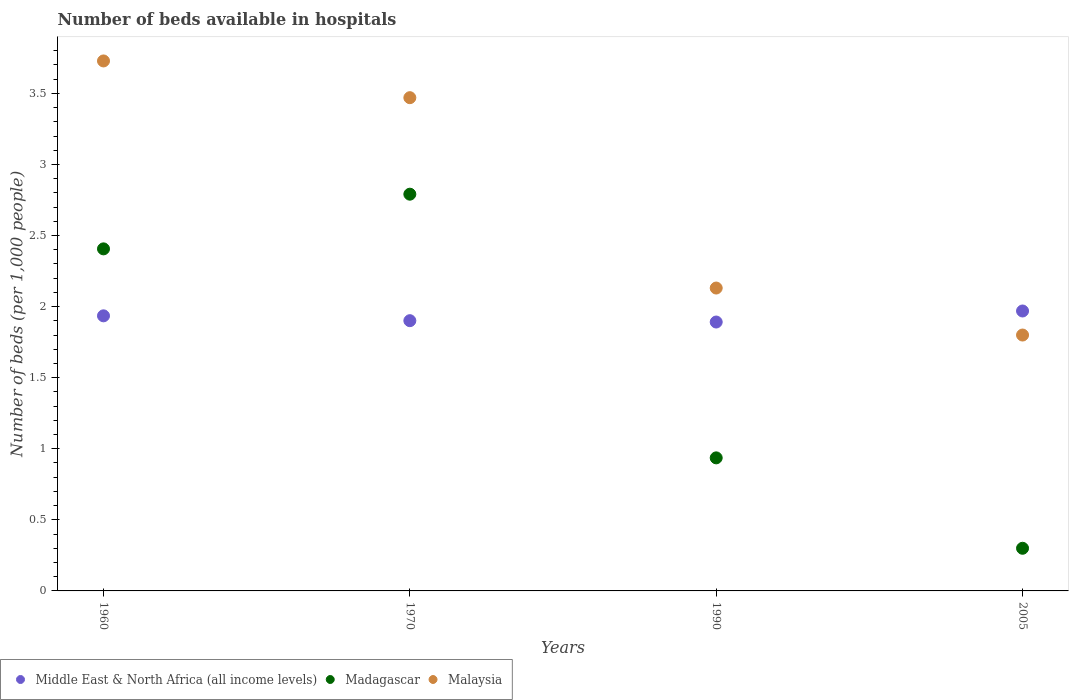How many different coloured dotlines are there?
Provide a short and direct response. 3. Is the number of dotlines equal to the number of legend labels?
Offer a terse response. Yes. What is the number of beds in the hospiatls of in Madagascar in 1990?
Your answer should be very brief. 0.94. Across all years, what is the maximum number of beds in the hospiatls of in Malaysia?
Make the answer very short. 3.73. Across all years, what is the minimum number of beds in the hospiatls of in Middle East & North Africa (all income levels)?
Offer a very short reply. 1.89. What is the total number of beds in the hospiatls of in Madagascar in the graph?
Your answer should be very brief. 6.43. What is the difference between the number of beds in the hospiatls of in Middle East & North Africa (all income levels) in 1960 and that in 1990?
Your response must be concise. 0.04. What is the difference between the number of beds in the hospiatls of in Middle East & North Africa (all income levels) in 1960 and the number of beds in the hospiatls of in Madagascar in 2005?
Keep it short and to the point. 1.64. What is the average number of beds in the hospiatls of in Middle East & North Africa (all income levels) per year?
Offer a very short reply. 1.92. In the year 2005, what is the difference between the number of beds in the hospiatls of in Madagascar and number of beds in the hospiatls of in Middle East & North Africa (all income levels)?
Give a very brief answer. -1.67. What is the ratio of the number of beds in the hospiatls of in Madagascar in 1960 to that in 2005?
Your response must be concise. 8.02. What is the difference between the highest and the second highest number of beds in the hospiatls of in Madagascar?
Provide a succinct answer. 0.38. What is the difference between the highest and the lowest number of beds in the hospiatls of in Malaysia?
Your response must be concise. 1.93. In how many years, is the number of beds in the hospiatls of in Middle East & North Africa (all income levels) greater than the average number of beds in the hospiatls of in Middle East & North Africa (all income levels) taken over all years?
Give a very brief answer. 2. Is the sum of the number of beds in the hospiatls of in Malaysia in 1970 and 2005 greater than the maximum number of beds in the hospiatls of in Middle East & North Africa (all income levels) across all years?
Offer a terse response. Yes. Is it the case that in every year, the sum of the number of beds in the hospiatls of in Middle East & North Africa (all income levels) and number of beds in the hospiatls of in Madagascar  is greater than the number of beds in the hospiatls of in Malaysia?
Provide a short and direct response. Yes. Is the number of beds in the hospiatls of in Middle East & North Africa (all income levels) strictly greater than the number of beds in the hospiatls of in Malaysia over the years?
Offer a very short reply. No. Is the number of beds in the hospiatls of in Middle East & North Africa (all income levels) strictly less than the number of beds in the hospiatls of in Madagascar over the years?
Your answer should be compact. No. Are the values on the major ticks of Y-axis written in scientific E-notation?
Your answer should be compact. No. Does the graph contain any zero values?
Your response must be concise. No. How many legend labels are there?
Offer a very short reply. 3. What is the title of the graph?
Your answer should be compact. Number of beds available in hospitals. What is the label or title of the X-axis?
Ensure brevity in your answer.  Years. What is the label or title of the Y-axis?
Provide a succinct answer. Number of beds (per 1,0 people). What is the Number of beds (per 1,000 people) of Middle East & North Africa (all income levels) in 1960?
Your response must be concise. 1.94. What is the Number of beds (per 1,000 people) of Madagascar in 1960?
Your answer should be very brief. 2.41. What is the Number of beds (per 1,000 people) in Malaysia in 1960?
Give a very brief answer. 3.73. What is the Number of beds (per 1,000 people) of Middle East & North Africa (all income levels) in 1970?
Provide a succinct answer. 1.9. What is the Number of beds (per 1,000 people) in Madagascar in 1970?
Keep it short and to the point. 2.79. What is the Number of beds (per 1,000 people) in Malaysia in 1970?
Your answer should be compact. 3.47. What is the Number of beds (per 1,000 people) of Middle East & North Africa (all income levels) in 1990?
Give a very brief answer. 1.89. What is the Number of beds (per 1,000 people) in Madagascar in 1990?
Your answer should be compact. 0.94. What is the Number of beds (per 1,000 people) in Malaysia in 1990?
Provide a short and direct response. 2.13. What is the Number of beds (per 1,000 people) of Middle East & North Africa (all income levels) in 2005?
Ensure brevity in your answer.  1.97. What is the Number of beds (per 1,000 people) in Madagascar in 2005?
Ensure brevity in your answer.  0.3. What is the Number of beds (per 1,000 people) of Malaysia in 2005?
Provide a succinct answer. 1.8. Across all years, what is the maximum Number of beds (per 1,000 people) of Middle East & North Africa (all income levels)?
Provide a succinct answer. 1.97. Across all years, what is the maximum Number of beds (per 1,000 people) of Madagascar?
Provide a succinct answer. 2.79. Across all years, what is the maximum Number of beds (per 1,000 people) of Malaysia?
Provide a short and direct response. 3.73. Across all years, what is the minimum Number of beds (per 1,000 people) in Middle East & North Africa (all income levels)?
Make the answer very short. 1.89. Across all years, what is the minimum Number of beds (per 1,000 people) in Madagascar?
Your response must be concise. 0.3. What is the total Number of beds (per 1,000 people) of Middle East & North Africa (all income levels) in the graph?
Offer a very short reply. 7.7. What is the total Number of beds (per 1,000 people) in Madagascar in the graph?
Provide a short and direct response. 6.43. What is the total Number of beds (per 1,000 people) of Malaysia in the graph?
Offer a terse response. 11.13. What is the difference between the Number of beds (per 1,000 people) in Middle East & North Africa (all income levels) in 1960 and that in 1970?
Ensure brevity in your answer.  0.03. What is the difference between the Number of beds (per 1,000 people) of Madagascar in 1960 and that in 1970?
Make the answer very short. -0.38. What is the difference between the Number of beds (per 1,000 people) of Malaysia in 1960 and that in 1970?
Keep it short and to the point. 0.26. What is the difference between the Number of beds (per 1,000 people) in Middle East & North Africa (all income levels) in 1960 and that in 1990?
Provide a short and direct response. 0.04. What is the difference between the Number of beds (per 1,000 people) in Madagascar in 1960 and that in 1990?
Offer a terse response. 1.47. What is the difference between the Number of beds (per 1,000 people) in Malaysia in 1960 and that in 1990?
Keep it short and to the point. 1.6. What is the difference between the Number of beds (per 1,000 people) in Middle East & North Africa (all income levels) in 1960 and that in 2005?
Provide a succinct answer. -0.03. What is the difference between the Number of beds (per 1,000 people) in Madagascar in 1960 and that in 2005?
Make the answer very short. 2.11. What is the difference between the Number of beds (per 1,000 people) of Malaysia in 1960 and that in 2005?
Provide a short and direct response. 1.93. What is the difference between the Number of beds (per 1,000 people) of Middle East & North Africa (all income levels) in 1970 and that in 1990?
Ensure brevity in your answer.  0.01. What is the difference between the Number of beds (per 1,000 people) of Madagascar in 1970 and that in 1990?
Give a very brief answer. 1.85. What is the difference between the Number of beds (per 1,000 people) of Malaysia in 1970 and that in 1990?
Your answer should be compact. 1.34. What is the difference between the Number of beds (per 1,000 people) of Middle East & North Africa (all income levels) in 1970 and that in 2005?
Your answer should be compact. -0.07. What is the difference between the Number of beds (per 1,000 people) in Madagascar in 1970 and that in 2005?
Your response must be concise. 2.49. What is the difference between the Number of beds (per 1,000 people) in Malaysia in 1970 and that in 2005?
Your answer should be compact. 1.67. What is the difference between the Number of beds (per 1,000 people) in Middle East & North Africa (all income levels) in 1990 and that in 2005?
Your response must be concise. -0.08. What is the difference between the Number of beds (per 1,000 people) of Madagascar in 1990 and that in 2005?
Make the answer very short. 0.64. What is the difference between the Number of beds (per 1,000 people) of Malaysia in 1990 and that in 2005?
Ensure brevity in your answer.  0.33. What is the difference between the Number of beds (per 1,000 people) in Middle East & North Africa (all income levels) in 1960 and the Number of beds (per 1,000 people) in Madagascar in 1970?
Offer a terse response. -0.86. What is the difference between the Number of beds (per 1,000 people) of Middle East & North Africa (all income levels) in 1960 and the Number of beds (per 1,000 people) of Malaysia in 1970?
Offer a terse response. -1.53. What is the difference between the Number of beds (per 1,000 people) in Madagascar in 1960 and the Number of beds (per 1,000 people) in Malaysia in 1970?
Give a very brief answer. -1.06. What is the difference between the Number of beds (per 1,000 people) of Middle East & North Africa (all income levels) in 1960 and the Number of beds (per 1,000 people) of Madagascar in 1990?
Your answer should be very brief. 1. What is the difference between the Number of beds (per 1,000 people) of Middle East & North Africa (all income levels) in 1960 and the Number of beds (per 1,000 people) of Malaysia in 1990?
Give a very brief answer. -0.2. What is the difference between the Number of beds (per 1,000 people) in Madagascar in 1960 and the Number of beds (per 1,000 people) in Malaysia in 1990?
Your answer should be compact. 0.28. What is the difference between the Number of beds (per 1,000 people) of Middle East & North Africa (all income levels) in 1960 and the Number of beds (per 1,000 people) of Madagascar in 2005?
Ensure brevity in your answer.  1.64. What is the difference between the Number of beds (per 1,000 people) of Middle East & North Africa (all income levels) in 1960 and the Number of beds (per 1,000 people) of Malaysia in 2005?
Make the answer very short. 0.14. What is the difference between the Number of beds (per 1,000 people) of Madagascar in 1960 and the Number of beds (per 1,000 people) of Malaysia in 2005?
Provide a succinct answer. 0.61. What is the difference between the Number of beds (per 1,000 people) of Middle East & North Africa (all income levels) in 1970 and the Number of beds (per 1,000 people) of Malaysia in 1990?
Provide a short and direct response. -0.23. What is the difference between the Number of beds (per 1,000 people) of Madagascar in 1970 and the Number of beds (per 1,000 people) of Malaysia in 1990?
Keep it short and to the point. 0.66. What is the difference between the Number of beds (per 1,000 people) in Middle East & North Africa (all income levels) in 1970 and the Number of beds (per 1,000 people) in Madagascar in 2005?
Offer a terse response. 1.6. What is the difference between the Number of beds (per 1,000 people) in Middle East & North Africa (all income levels) in 1970 and the Number of beds (per 1,000 people) in Malaysia in 2005?
Your answer should be compact. 0.1. What is the difference between the Number of beds (per 1,000 people) of Middle East & North Africa (all income levels) in 1990 and the Number of beds (per 1,000 people) of Madagascar in 2005?
Provide a succinct answer. 1.59. What is the difference between the Number of beds (per 1,000 people) in Middle East & North Africa (all income levels) in 1990 and the Number of beds (per 1,000 people) in Malaysia in 2005?
Offer a very short reply. 0.09. What is the difference between the Number of beds (per 1,000 people) of Madagascar in 1990 and the Number of beds (per 1,000 people) of Malaysia in 2005?
Provide a succinct answer. -0.86. What is the average Number of beds (per 1,000 people) in Middle East & North Africa (all income levels) per year?
Offer a terse response. 1.92. What is the average Number of beds (per 1,000 people) of Madagascar per year?
Keep it short and to the point. 1.61. What is the average Number of beds (per 1,000 people) in Malaysia per year?
Your response must be concise. 2.78. In the year 1960, what is the difference between the Number of beds (per 1,000 people) of Middle East & North Africa (all income levels) and Number of beds (per 1,000 people) of Madagascar?
Your answer should be very brief. -0.47. In the year 1960, what is the difference between the Number of beds (per 1,000 people) of Middle East & North Africa (all income levels) and Number of beds (per 1,000 people) of Malaysia?
Provide a succinct answer. -1.79. In the year 1960, what is the difference between the Number of beds (per 1,000 people) of Madagascar and Number of beds (per 1,000 people) of Malaysia?
Give a very brief answer. -1.32. In the year 1970, what is the difference between the Number of beds (per 1,000 people) of Middle East & North Africa (all income levels) and Number of beds (per 1,000 people) of Madagascar?
Your answer should be compact. -0.89. In the year 1970, what is the difference between the Number of beds (per 1,000 people) in Middle East & North Africa (all income levels) and Number of beds (per 1,000 people) in Malaysia?
Provide a short and direct response. -1.57. In the year 1970, what is the difference between the Number of beds (per 1,000 people) in Madagascar and Number of beds (per 1,000 people) in Malaysia?
Offer a terse response. -0.68. In the year 1990, what is the difference between the Number of beds (per 1,000 people) of Middle East & North Africa (all income levels) and Number of beds (per 1,000 people) of Madagascar?
Provide a short and direct response. 0.96. In the year 1990, what is the difference between the Number of beds (per 1,000 people) in Middle East & North Africa (all income levels) and Number of beds (per 1,000 people) in Malaysia?
Your response must be concise. -0.24. In the year 1990, what is the difference between the Number of beds (per 1,000 people) in Madagascar and Number of beds (per 1,000 people) in Malaysia?
Offer a terse response. -1.19. In the year 2005, what is the difference between the Number of beds (per 1,000 people) in Middle East & North Africa (all income levels) and Number of beds (per 1,000 people) in Madagascar?
Give a very brief answer. 1.67. In the year 2005, what is the difference between the Number of beds (per 1,000 people) of Middle East & North Africa (all income levels) and Number of beds (per 1,000 people) of Malaysia?
Your answer should be compact. 0.17. In the year 2005, what is the difference between the Number of beds (per 1,000 people) of Madagascar and Number of beds (per 1,000 people) of Malaysia?
Ensure brevity in your answer.  -1.5. What is the ratio of the Number of beds (per 1,000 people) of Middle East & North Africa (all income levels) in 1960 to that in 1970?
Your answer should be very brief. 1.02. What is the ratio of the Number of beds (per 1,000 people) of Madagascar in 1960 to that in 1970?
Keep it short and to the point. 0.86. What is the ratio of the Number of beds (per 1,000 people) of Malaysia in 1960 to that in 1970?
Give a very brief answer. 1.07. What is the ratio of the Number of beds (per 1,000 people) of Middle East & North Africa (all income levels) in 1960 to that in 1990?
Your answer should be compact. 1.02. What is the ratio of the Number of beds (per 1,000 people) of Madagascar in 1960 to that in 1990?
Offer a terse response. 2.57. What is the ratio of the Number of beds (per 1,000 people) of Malaysia in 1960 to that in 1990?
Your answer should be compact. 1.75. What is the ratio of the Number of beds (per 1,000 people) of Middle East & North Africa (all income levels) in 1960 to that in 2005?
Offer a very short reply. 0.98. What is the ratio of the Number of beds (per 1,000 people) of Madagascar in 1960 to that in 2005?
Your response must be concise. 8.02. What is the ratio of the Number of beds (per 1,000 people) of Malaysia in 1960 to that in 2005?
Offer a very short reply. 2.07. What is the ratio of the Number of beds (per 1,000 people) in Middle East & North Africa (all income levels) in 1970 to that in 1990?
Your answer should be compact. 1. What is the ratio of the Number of beds (per 1,000 people) of Madagascar in 1970 to that in 1990?
Offer a very short reply. 2.98. What is the ratio of the Number of beds (per 1,000 people) of Malaysia in 1970 to that in 1990?
Give a very brief answer. 1.63. What is the ratio of the Number of beds (per 1,000 people) in Middle East & North Africa (all income levels) in 1970 to that in 2005?
Provide a short and direct response. 0.97. What is the ratio of the Number of beds (per 1,000 people) in Madagascar in 1970 to that in 2005?
Your answer should be very brief. 9.3. What is the ratio of the Number of beds (per 1,000 people) of Malaysia in 1970 to that in 2005?
Ensure brevity in your answer.  1.93. What is the ratio of the Number of beds (per 1,000 people) of Middle East & North Africa (all income levels) in 1990 to that in 2005?
Ensure brevity in your answer.  0.96. What is the ratio of the Number of beds (per 1,000 people) of Madagascar in 1990 to that in 2005?
Offer a very short reply. 3.12. What is the ratio of the Number of beds (per 1,000 people) in Malaysia in 1990 to that in 2005?
Give a very brief answer. 1.18. What is the difference between the highest and the second highest Number of beds (per 1,000 people) in Middle East & North Africa (all income levels)?
Make the answer very short. 0.03. What is the difference between the highest and the second highest Number of beds (per 1,000 people) of Madagascar?
Give a very brief answer. 0.38. What is the difference between the highest and the second highest Number of beds (per 1,000 people) of Malaysia?
Make the answer very short. 0.26. What is the difference between the highest and the lowest Number of beds (per 1,000 people) of Middle East & North Africa (all income levels)?
Your response must be concise. 0.08. What is the difference between the highest and the lowest Number of beds (per 1,000 people) in Madagascar?
Your response must be concise. 2.49. What is the difference between the highest and the lowest Number of beds (per 1,000 people) of Malaysia?
Give a very brief answer. 1.93. 